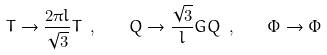Convert formula to latex. <formula><loc_0><loc_0><loc_500><loc_500>T \rightarrow { \frac { 2 \pi l } { \sqrt { 3 } } } T \ , \quad Q \rightarrow { \frac { \sqrt { 3 } } { l } } G Q \ , \quad \Phi \rightarrow \Phi</formula> 